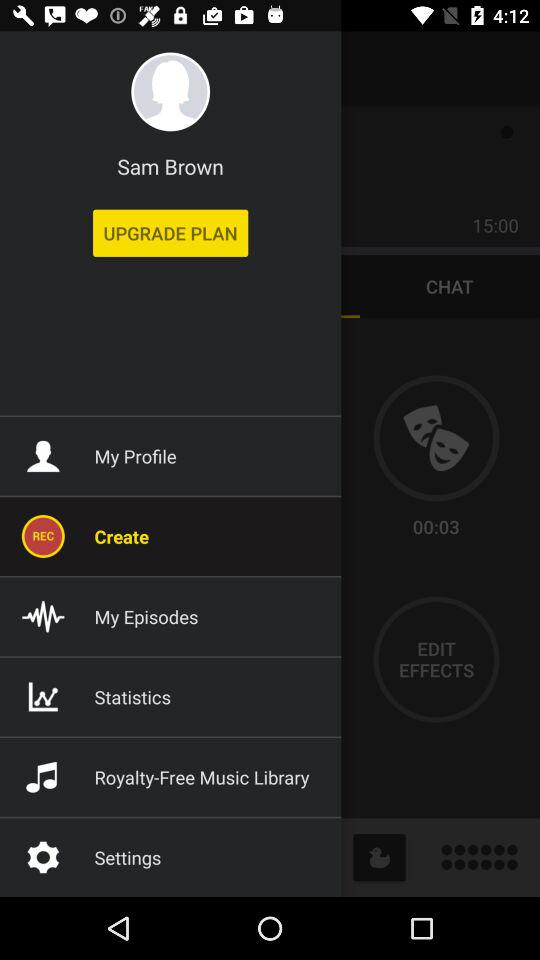What is the name of the user? The name of the user is Sam Brown. 